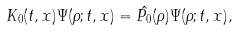<formula> <loc_0><loc_0><loc_500><loc_500>K _ { 0 } ( t , x ) \Psi ( \rho ; t , x ) = \hat { P _ { 0 } } ( \rho ) { \Psi } ( \rho ; t , x ) ,</formula> 